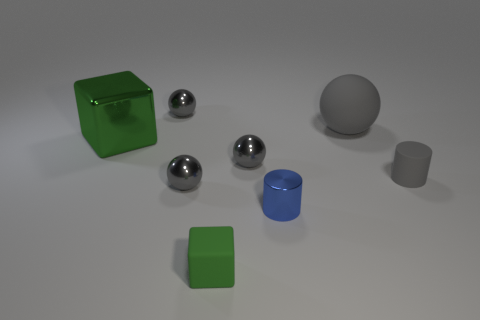Add 2 tiny red things. How many objects exist? 10 Subtract all large matte balls. How many balls are left? 3 Subtract 2 cylinders. How many cylinders are left? 0 Subtract 1 gray cylinders. How many objects are left? 7 Subtract all cylinders. How many objects are left? 6 Subtract all green balls. Subtract all brown cylinders. How many balls are left? 4 Subtract all big green rubber cubes. Subtract all small blue shiny cylinders. How many objects are left? 7 Add 5 matte cubes. How many matte cubes are left? 6 Add 3 cylinders. How many cylinders exist? 5 Subtract all blue cylinders. How many cylinders are left? 1 